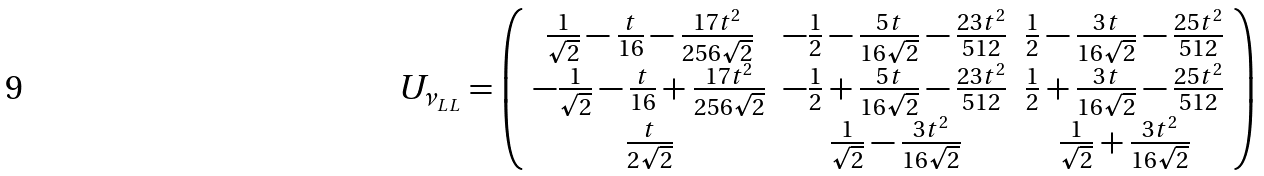Convert formula to latex. <formula><loc_0><loc_0><loc_500><loc_500>U _ { \nu _ { L L } } = \left ( \begin{array} { c c c } \frac { 1 } { \sqrt { 2 } } - \frac { t } { 1 6 } - \frac { 1 7 t ^ { 2 } } { 2 5 6 \sqrt { 2 } } & - \frac { 1 } { 2 } - \frac { 5 t } { 1 6 \sqrt { 2 } } - \frac { 2 3 t ^ { 2 } } { 5 1 2 } & \frac { 1 } { 2 } - \frac { 3 t } { 1 6 \sqrt { 2 } } - \frac { 2 5 t ^ { 2 } } { 5 1 2 } \\ - \frac { 1 } { \sqrt { 2 } } - \frac { t } { 1 6 } + \frac { 1 7 t ^ { 2 } } { 2 5 6 \sqrt { 2 } } & - \frac { 1 } { 2 } + \frac { 5 t } { 1 6 \sqrt { 2 } } - \frac { 2 3 t ^ { 2 } } { 5 1 2 } & \frac { 1 } { 2 } + \frac { 3 t } { 1 6 \sqrt { 2 } } - \frac { 2 5 t ^ { 2 } } { 5 1 2 } \\ \frac { t } { 2 \sqrt { 2 } } & \frac { 1 } { \sqrt { 2 } } - \frac { 3 t ^ { 2 } } { 1 6 \sqrt { 2 } } & \frac { 1 } { \sqrt { 2 } } + \frac { 3 t ^ { 2 } } { 1 6 \sqrt { 2 } } \end{array} \right )</formula> 